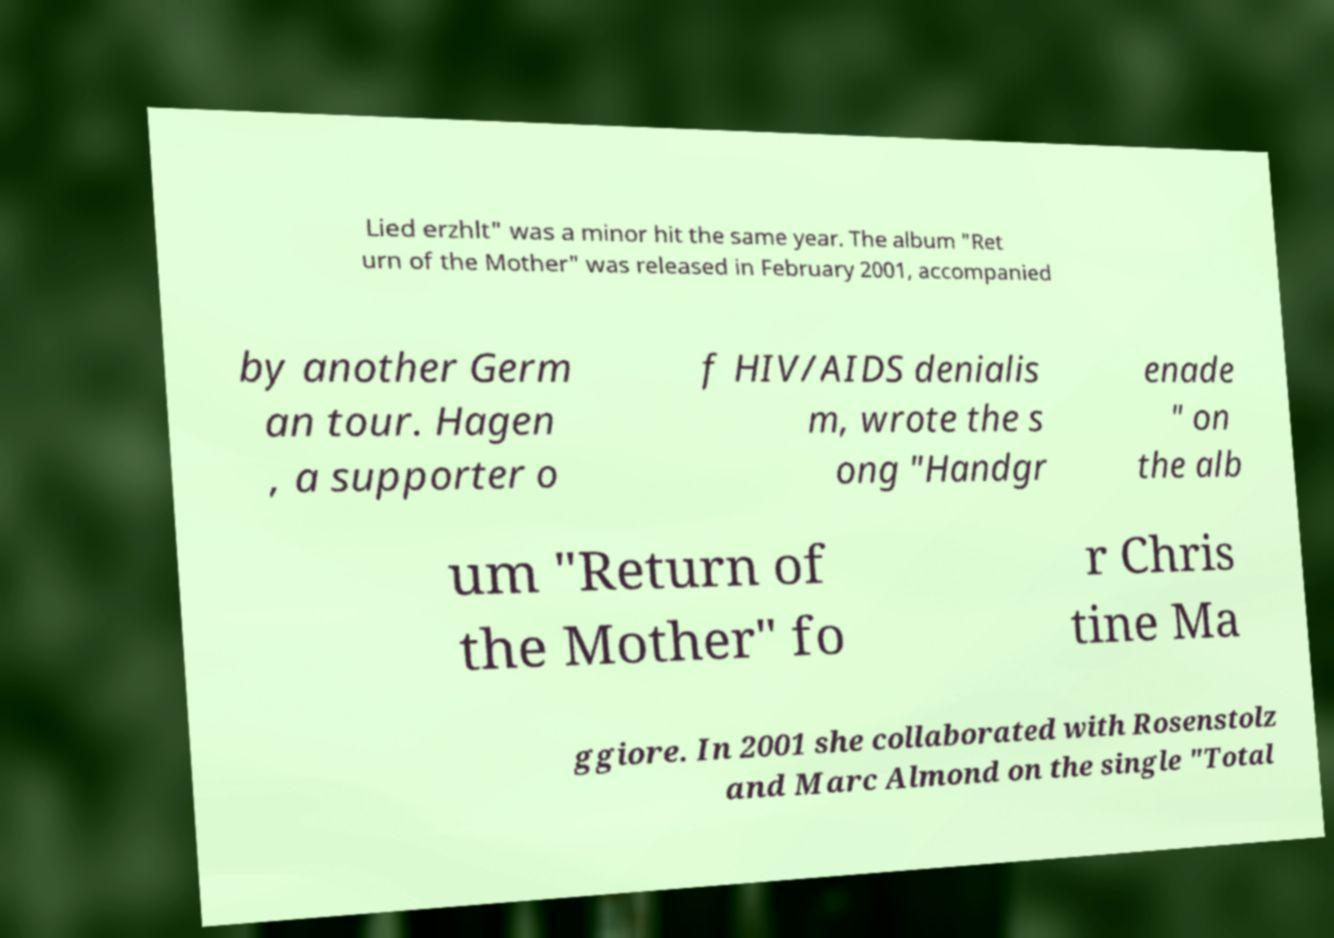Could you assist in decoding the text presented in this image and type it out clearly? Lied erzhlt" was a minor hit the same year. The album "Ret urn of the Mother" was released in February 2001, accompanied by another Germ an tour. Hagen , a supporter o f HIV/AIDS denialis m, wrote the s ong "Handgr enade " on the alb um "Return of the Mother" fo r Chris tine Ma ggiore. In 2001 she collaborated with Rosenstolz and Marc Almond on the single "Total 